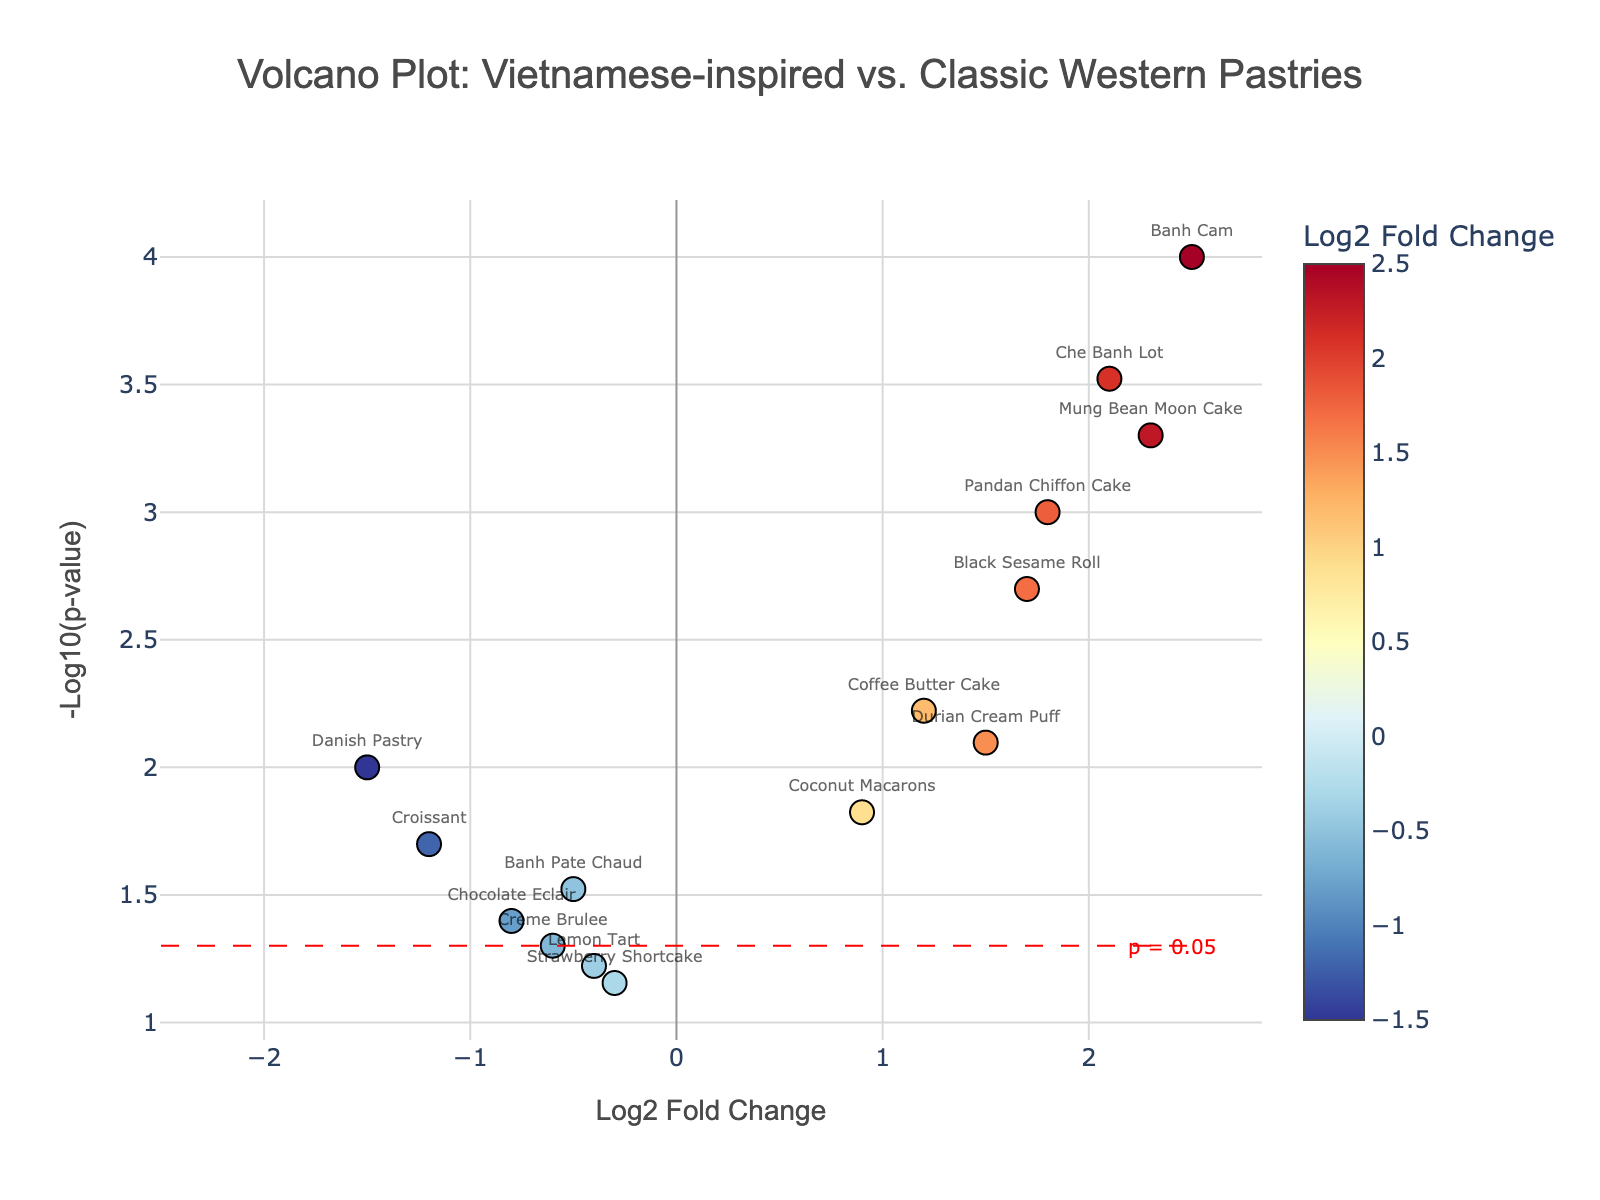What's the title of the figure? The title is displayed at the top of the chart. It reads 'Volcano Plot: Vietnamese-inspired vs. Classic Western Pastries'. This title gives an overview of what the figure is about.
Answer: Volcano Plot: Vietnamese-inspired vs. Classic Western Pastries Which pastries have a log2 fold change greater than 2? By looking at the x-axis labeled 'Log2 Fold Change' and finding points to the right of 2, you can see which pastries are those. The specific pastries are listed in the hover text near those points.
Answer: Mung Bean Moon Cake, Che Banh Lot, Banh Cam How many pastries have a p-value less than 0.05? Points with a y-axis value greater than 1.3 (-log10(0.05)) meet this criterion. Count the number of such points.
Answer: 11 Which pastry has the highest -log10(p-value)? Find the point with the highest y-axis value. The hover text for this point will display the corresponding pastry.
Answer: Banh Cam Which classic Western pastries show a negative log2 fold change? Look for points to the left of 0 on the x-axis. Use the hover text to identify which come from classic Western pastries.
Answer: Croissant, Danish Pastry, Creme Brulee, Chocolate Eclair What is the range of log2 fold change values? Identify the minimum and maximum x-axis values to determine the range. The pastries' log2 fold changes span from -1.5 to 2.5.
Answer: -1.5 to 2.5 Which pastries have a log2 fold change between 1.5 and 2, and a p-value less than 0.01? Look at the area of the graph with x-values between 1.5 and 2 and y-values greater than 2 (corresponding to a p-value < 0.01).
Answer: Pandan Chiffon Cake, Durian Cream Puff, Black Sesame Roll Are there more Vietnamese-inspired pastries or classic Western pastries with a -log10(p-value) greater than 2? Count the points above y = 2 for each category.
Answer: More Vietnamese-inspired pastries Which has a greater p-value: Chocolate Eclair or Lemon Tart? Check the y-values of the points representing these pastries. Lower y-values correlate with higher p-values.
Answer: Lemon Tart Are there any pastries with a log2 fold change less than -1 and a p-value below 0.05? Look in the bottom left area of the plot (log2 fold change < -1 and y-value > 1.3).
Answer: Croissant, Danish Pastry 